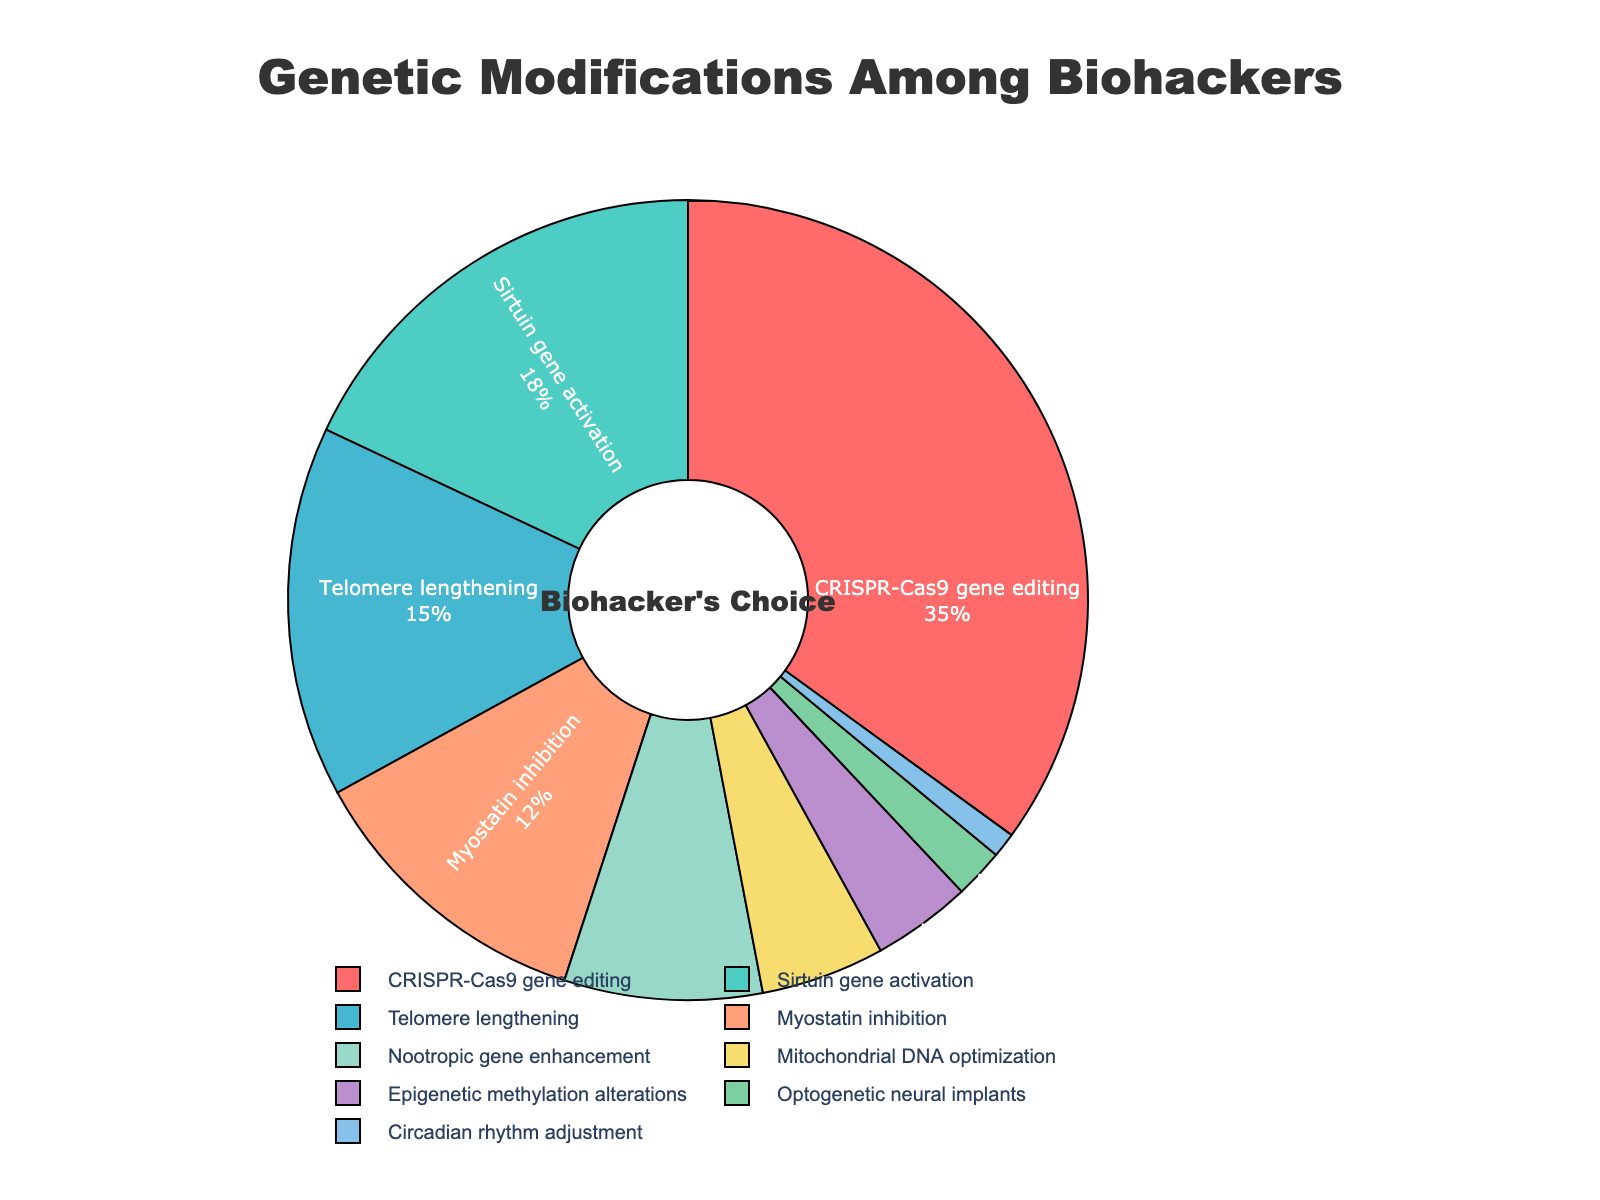Which genetic modification is the most popular among biohackers? The most popular genetic modification can be identified by looking for the largest segment in the pie chart. The segment labeled "CRISPR-Cas9 gene editing" is the largest, indicating it is the most popular.
Answer: CRISPR-Cas9 gene editing Which modifications have similar popularity levels? To find modifications with similar popularity, look for segments with percentages that are close to each other. "Sirtuin gene activation" has 18%, and "Telomere lengthening" has 15%, which are close to each other.
Answer: Sirtuin gene activation and Telomere lengthening What is the second least common genetic modification? To identify the second least common modification, first find the smallest segment (which is "Circadian rhythm adjustment" at 1%). Then find the next smallest segment, which is "Optogenetic neural implants" at 2%.
Answer: Optogenetic neural implants What is the combined percentage of 'Nootropic gene enhancement' and 'Mitochondrial DNA optimization'? Sum the percentages for "Nootropic gene enhancement" (8%) and "Mitochondrial DNA optimization" (5%) to get the combined percentage: 8% + 5% = 13%
Answer: 13% Which genetic modification category has a yellow color? To determine the visually yellow-colored segment, look at the pie chart's color scheme. "Mitochondrial DNA optimization" is colored yellow.
Answer: Mitochondrial DNA optimization How does the popularity of 'Myostatin inhibition' compare to 'Telomere lengthening'? Compare the percentage of "Myostatin inhibition" (12%) with "Telomere lengthening" (15%). "Myostatin inhibition" is less popular than "Telomere lengthening".
Answer: Myostatin inhibition is less popular What is the total percentage for all genetic modifications related to DNA? Sum the percentages of modifications involving DNA: "CRISPR-Cas9 gene editing" (35%), "Mitochondrial DNA optimization" (5%), and "Telomere lengthening" (15%). Total = 35% + 5% + 15% = 55%
Answer: 55% What proportion of biohackers chose 'Epigenetic methylation alterations' or less popular methods? Sum the percentages of "Epigenetic methylation alterations" (4%), "Optogenetic neural implants" (2%), and "Circadian rhythm adjustment" (1%) to get the total: 4% + 2% + 1% = 7%
Answer: 7% Which color represents the least common modification in the chart? Identify the smallest segment, which is "Circadian rhythm adjustment" (1%). Look at the pie chart to find its color, which is light blue.
Answer: Light blue What is the difference in popularity between 'Sirtuin gene activation' and 'Nootropic gene enhancement'? Subtract the percentage of "Nootropic gene enhancement" (8%) from "Sirtuin gene activation" (18%) to find the difference: 18% - 8% = 10%
Answer: 10% 